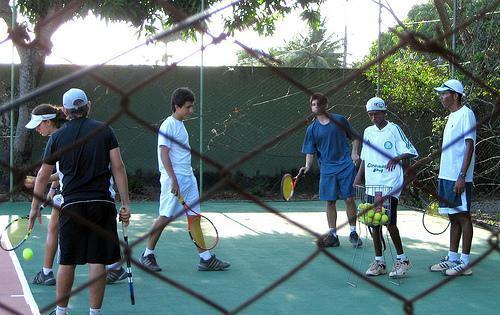How many people are wearing hats?
Give a very brief answer. 4. How many people are playing football?
Give a very brief answer. 0. 